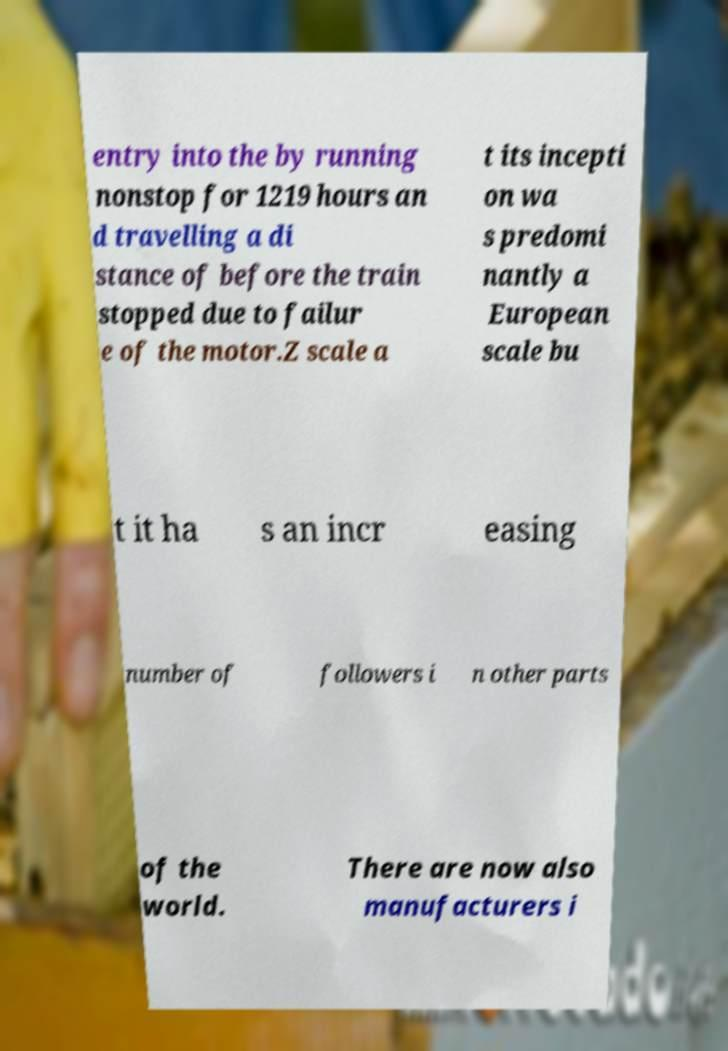Could you assist in decoding the text presented in this image and type it out clearly? entry into the by running nonstop for 1219 hours an d travelling a di stance of before the train stopped due to failur e of the motor.Z scale a t its incepti on wa s predomi nantly a European scale bu t it ha s an incr easing number of followers i n other parts of the world. There are now also manufacturers i 